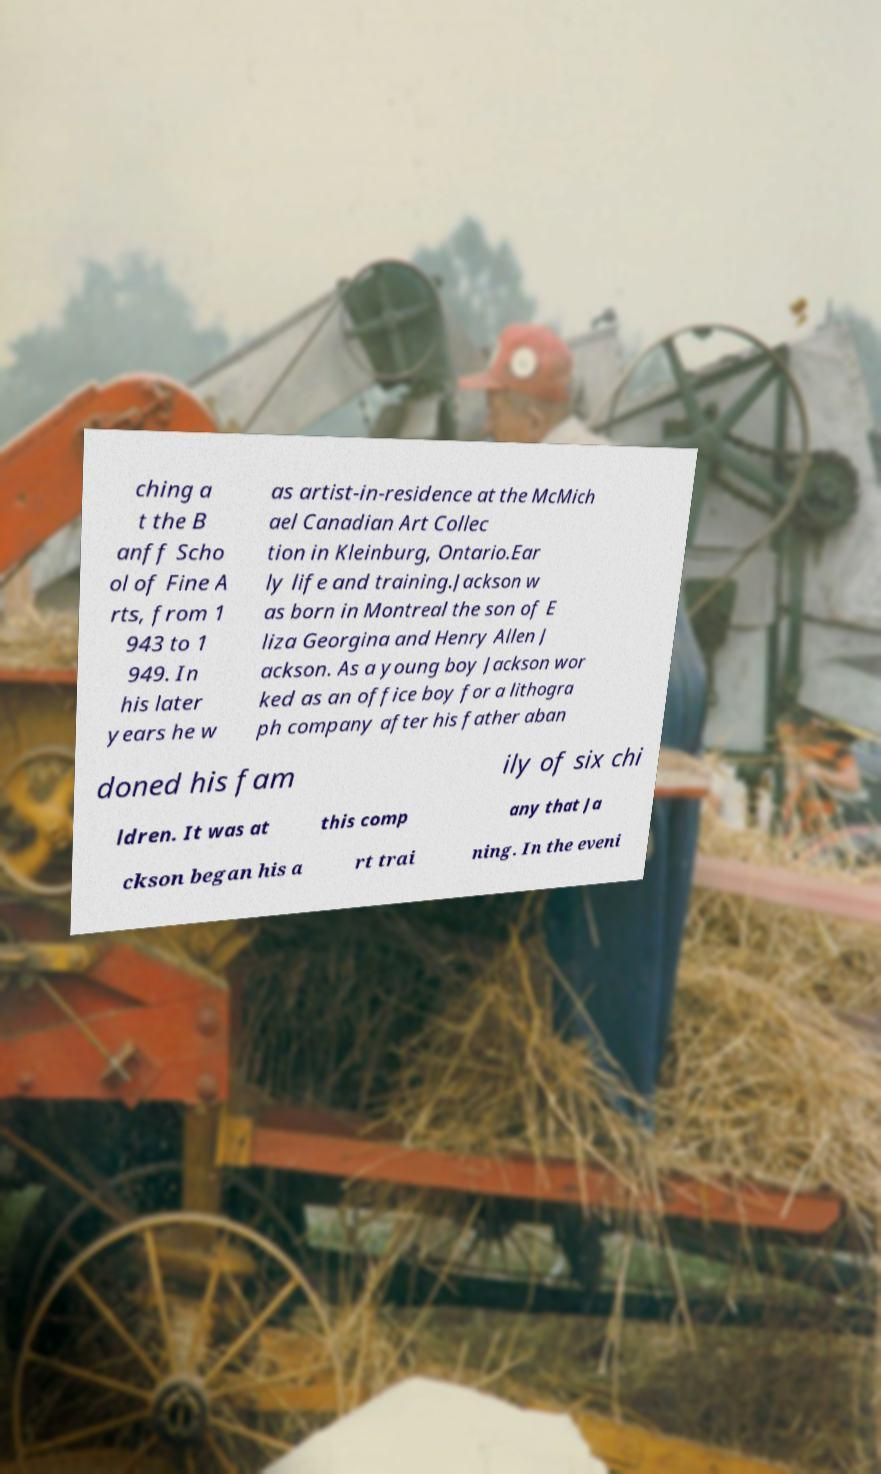Please read and relay the text visible in this image. What does it say? ching a t the B anff Scho ol of Fine A rts, from 1 943 to 1 949. In his later years he w as artist-in-residence at the McMich ael Canadian Art Collec tion in Kleinburg, Ontario.Ear ly life and training.Jackson w as born in Montreal the son of E liza Georgina and Henry Allen J ackson. As a young boy Jackson wor ked as an office boy for a lithogra ph company after his father aban doned his fam ily of six chi ldren. It was at this comp any that Ja ckson began his a rt trai ning. In the eveni 